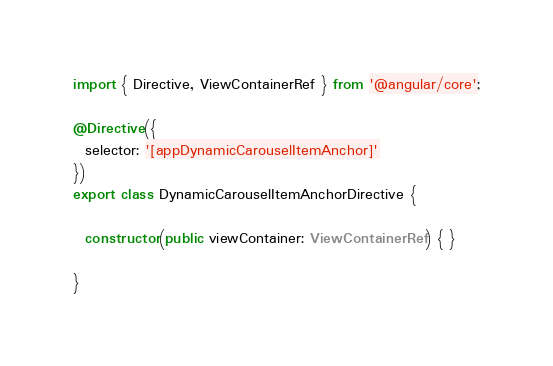Convert code to text. <code><loc_0><loc_0><loc_500><loc_500><_TypeScript_>import { Directive, ViewContainerRef } from '@angular/core';

@Directive({
  selector: '[appDynamicCarouselItemAnchor]'
})
export class DynamicCarouselItemAnchorDirective {

  constructor(public viewContainer: ViewContainerRef) { }

}
</code> 